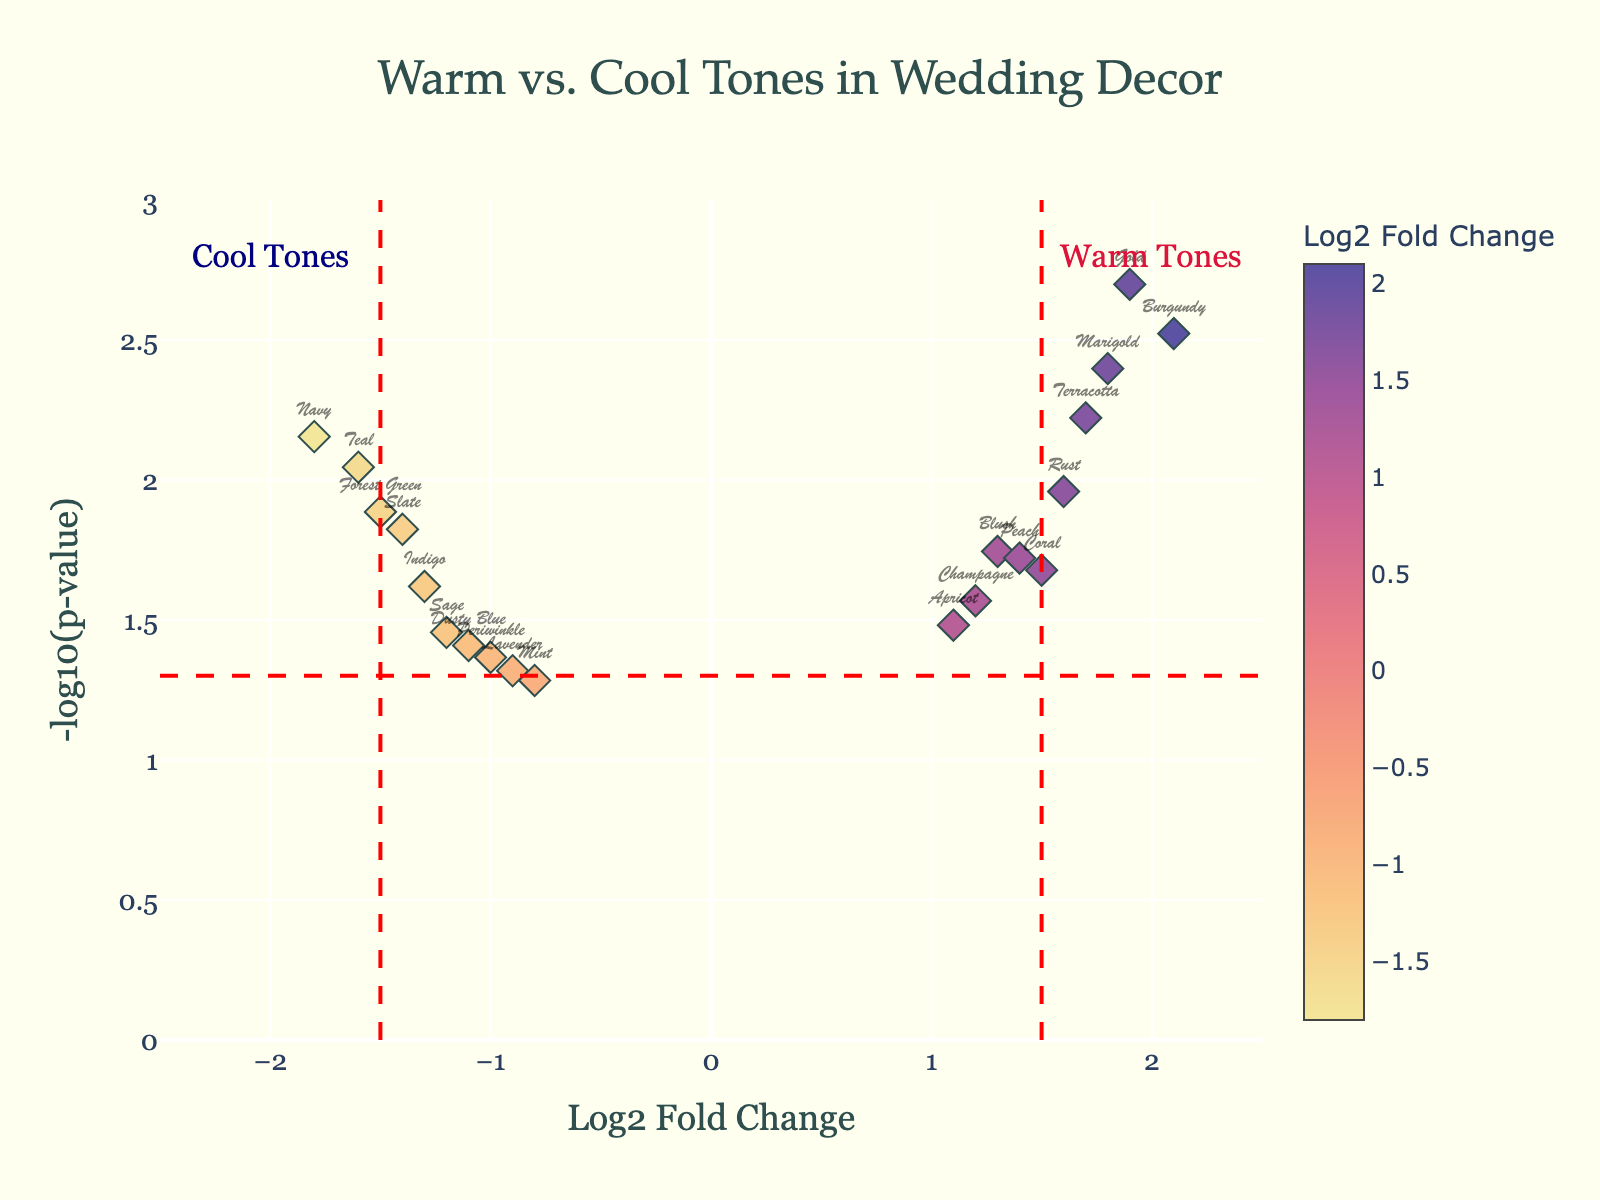How many data points are there in total? There are 20 colors represented as data points in the plot. Each color corresponds to a marker on the plot.
Answer: 20 Which tone (warm or cool) generally has higher Log2 Fold Change values? According to the plot, warm tones (positive Log2 Fold Change) have higher Log2 Fold Change values compared to cool tones (negative Log2 Fold Change). This is evident from more markers being present on the right side of the plot (positive Log2 Fold Change) indicating warm tones.
Answer: Warm tones What is the Log2 Fold Change value for 'Gold'? The plot indicates that 'Gold' is positioned at a Log2 Fold Change value close to 1.9. This can be identified by locating 'Gold' on the x-axis.
Answer: 1.9 Which cool tone color has the highest significance level? The significance level is indicated by the highest -log10(p-value). 'Navy' among cool tones has the highest -log10(p-value) as it lies at the topmost position on the y-axis compared to other cool tones.
Answer: Navy Compare the positions of 'Burgundy' and 'Navy'. Which one is more significant and why? 'Burgundy' appears higher on the y-axis than 'Navy', suggesting a lower p-value and hence greater significance. Significance in the plot is represented by higher -log10(p-value) values. The color on top has more significance.
Answer: Burgundy What threshold lines are used for significance and fold change in the plot? The plot uses vertical red dashed lines at x = -1.5 and x = 1.5 to denote the fold change thresholds, and a horizontal red dashed line at y = -log10(0.05) to denote the significance threshold.
Answer: x = -1.5, x = 1.5, y = -log10(0.05) Between peach and terracotta, which color shows higher fold change and which is more significant? 'Terracotta' has a higher Log2 Fold Change value as it is positioned further right on the x-axis compared to 'Peach'. Comparing their y-values, 'Terracotta' is also positioned higher, indicating a lower p-value and thus higher significance.
Answer: Terracotta How is the overall effectiveness of the cool tones compared to warm tones in wedding decor based on this plot? Warm tones generally show higher fold changes and more significant p-values (higher -log10(p-value)), indicating stronger effectiveness compared to cool tones, which are farther left on the x-axis and not as high on the y-axis.
Answer: Warm tones are more effective For the color 'Blush', what are the Log2 Fold Change and significance levels? 'Blush' is positioned at a Log2 Fold Change of approximately 1.3 and a -log10(p-value) of around 1.75, placing it on the right and above the significance threshold line.
Answer: Log2FC: 1.3, significance: ~1.75 